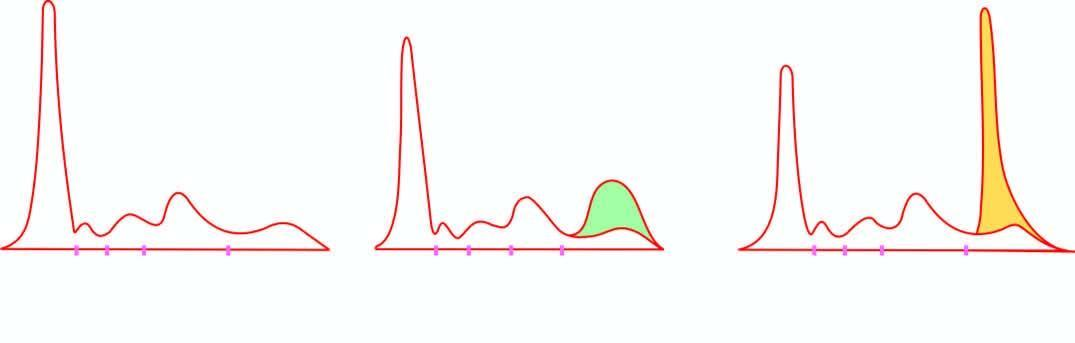what show normal serum pattern?
Answer the question using a single word or phrase. Serum electrophoresis 